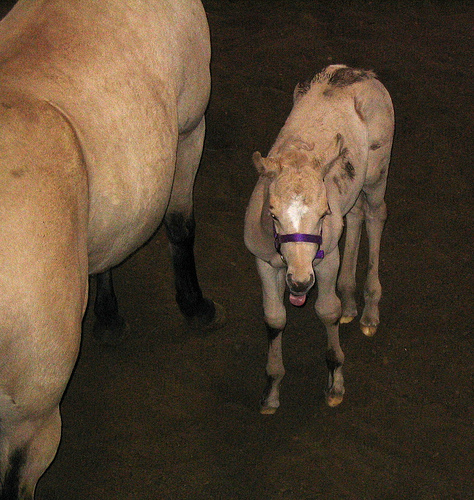<image>
Can you confirm if the calf is to the right of the horse? Yes. From this viewpoint, the calf is positioned to the right side relative to the horse. 